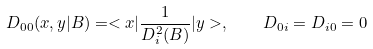<formula> <loc_0><loc_0><loc_500><loc_500>D _ { 0 0 } ( x , y | B ) = < x | \frac { 1 } { D _ { i } ^ { 2 } ( B ) } | y > , \quad D _ { 0 i } = D _ { i 0 } = 0</formula> 